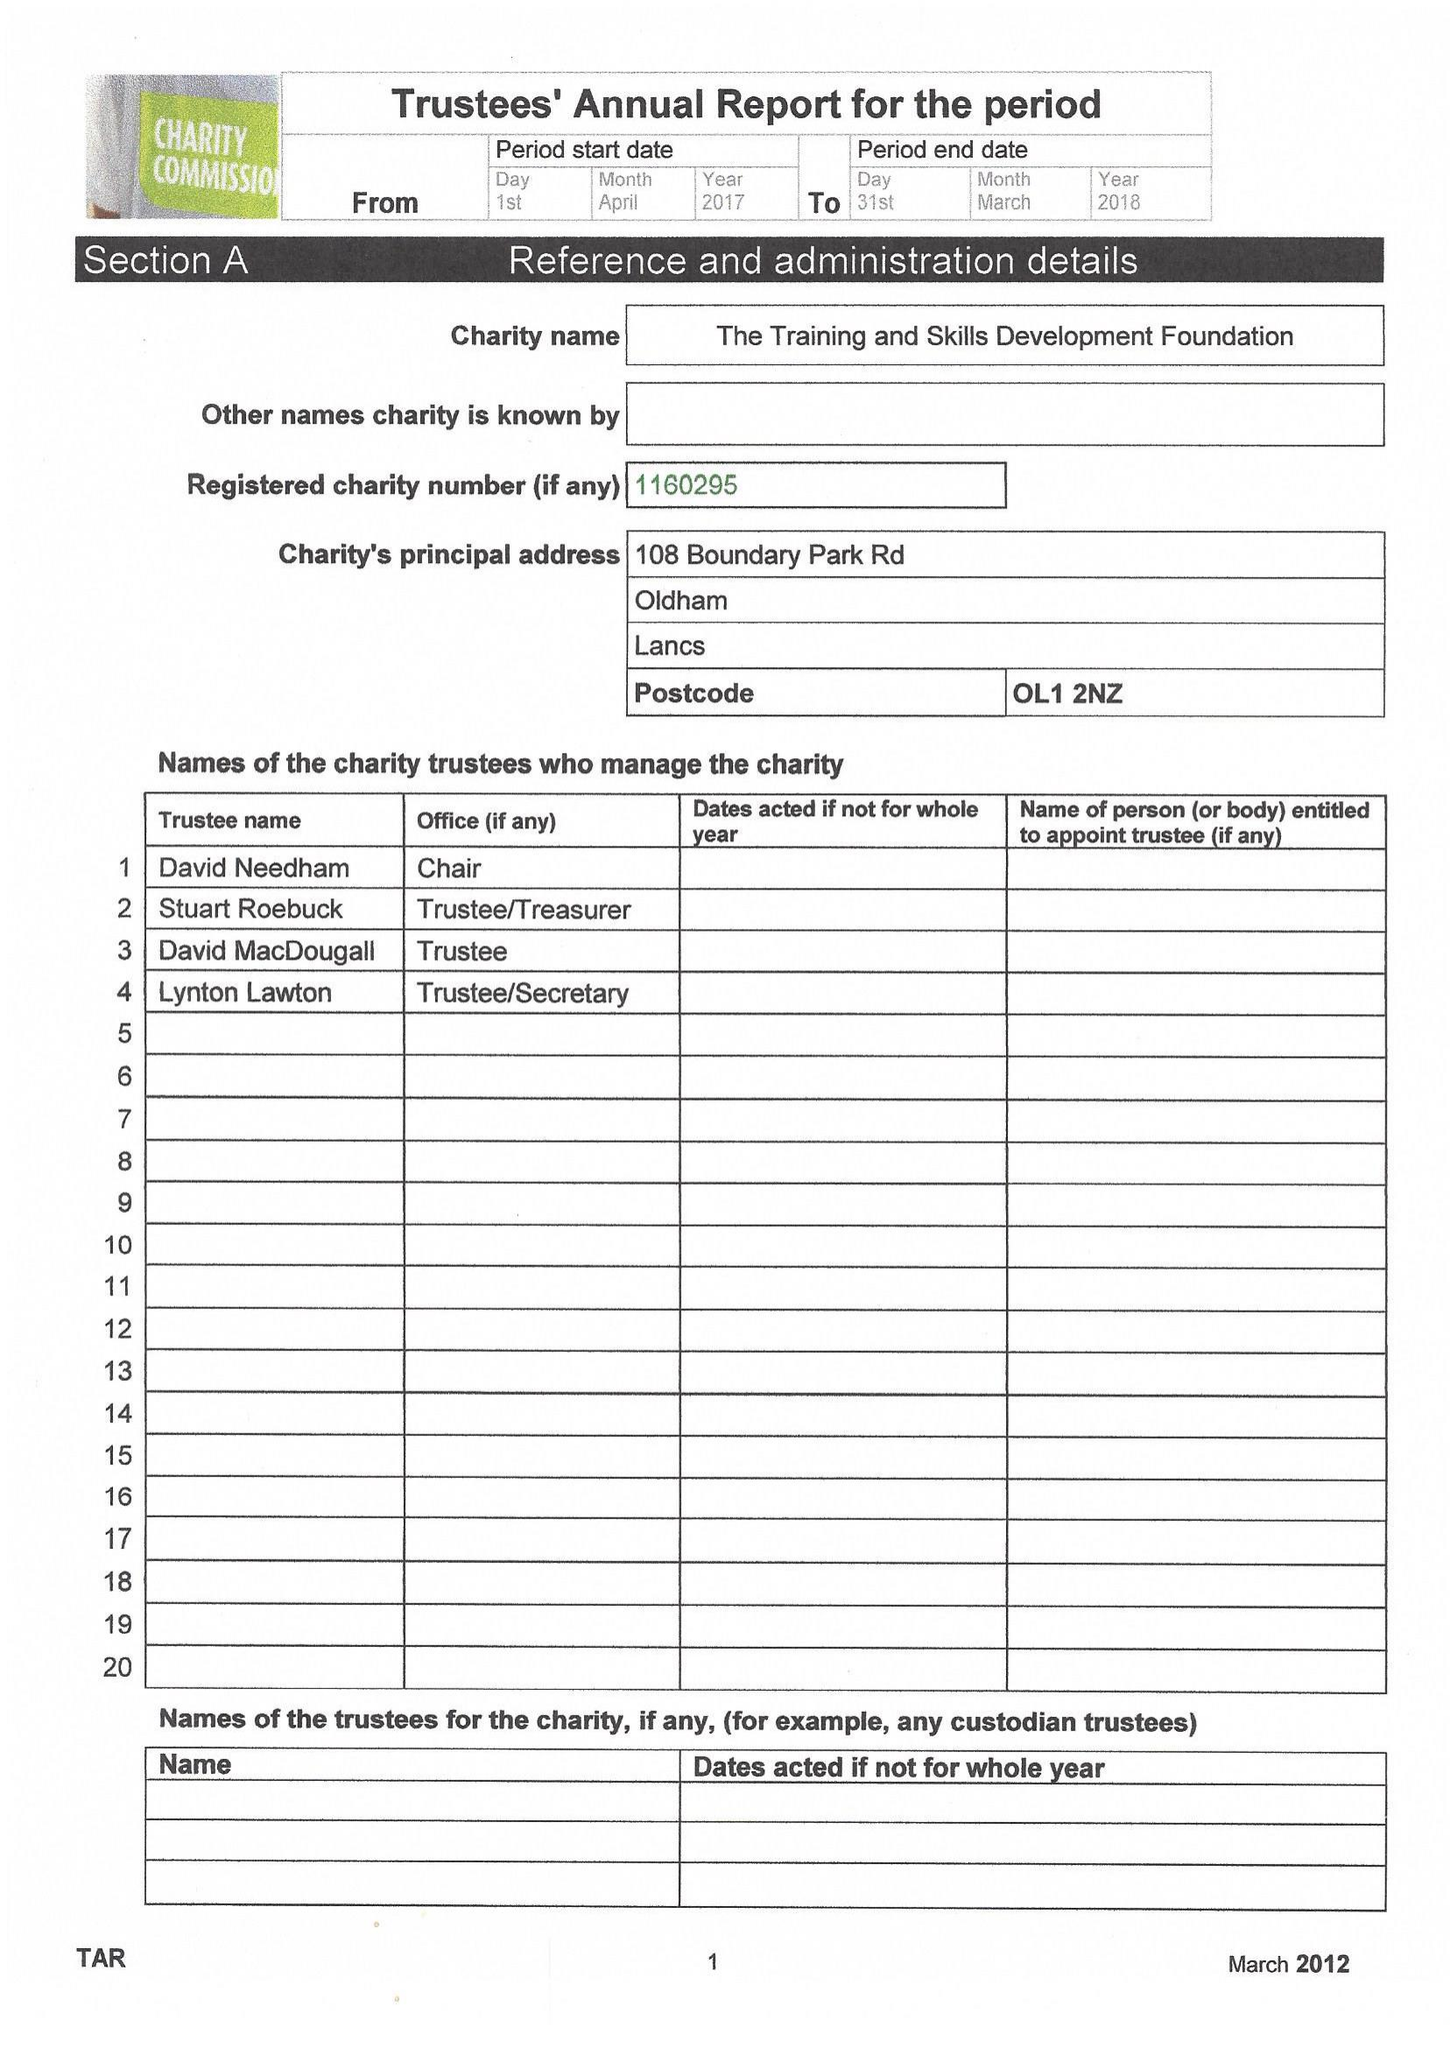What is the value for the address__postcode?
Answer the question using a single word or phrase. OL1 2NZ 